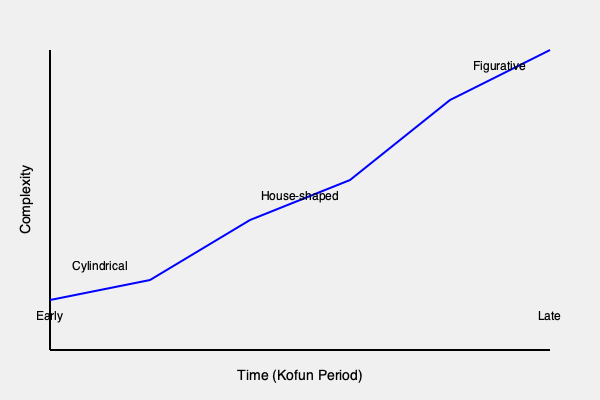Analyze the evolution of haniwa figurine styles and shapes throughout the Kofun period as depicted in the graph. What does the trend suggest about the development of haniwa craftsmanship and its cultural significance? To analyze the evolution of haniwa figurine styles and shapes throughout the Kofun period, we need to consider the following steps:

1. Early Kofun period:
   - The graph shows that early haniwa were relatively simple, primarily cylindrical in shape.
   - This suggests a basic form of craftsmanship, possibly focused on functionality rather than artistic expression.

2. Mid Kofun period:
   - There is a gradual increase in complexity, with the introduction of house-shaped haniwa.
   - This indicates a shift towards more elaborate designs, possibly reflecting changes in societal structures and beliefs.

3. Late Kofun period:
   - The graph shows a significant increase in complexity, culminating in figurative haniwa.
   - This represents a major leap in artistic skill and cultural expression.

4. Overall trend:
   - The graph demonstrates a clear progression from simple to complex forms over time.
   - This suggests a continuous development of craftsmanship and artistic techniques throughout the Kofun period.

5. Cultural significance:
   - The increasing complexity of haniwa designs likely reflects:
     a) Advancements in pottery techniques
     b) Changes in religious or funerary practices
     c) Growing social stratification and the need for more elaborate grave goods
     d) Increased resources devoted to funerary art, indicating its growing importance in Kofun society

6. Interpretation:
   - The evolution from cylindrical to figurative forms suggests a shift from abstract to more realistic representations of the world.
   - This could indicate changes in how the Kofun people perceived the afterlife and their relationship with the deceased.

The trend in the graph suggests a significant development in haniwa craftsmanship, reflecting broader cultural and societal changes throughout the Kofun period. The increasing complexity and realism of haniwa figurines indicate their growing importance in funerary practices and as expressions of artistic and cultural sophistication.
Answer: Increasing complexity from cylindrical to figurative forms, reflecting advancements in craftsmanship, changing funerary practices, and growing cultural sophistication throughout the Kofun period. 